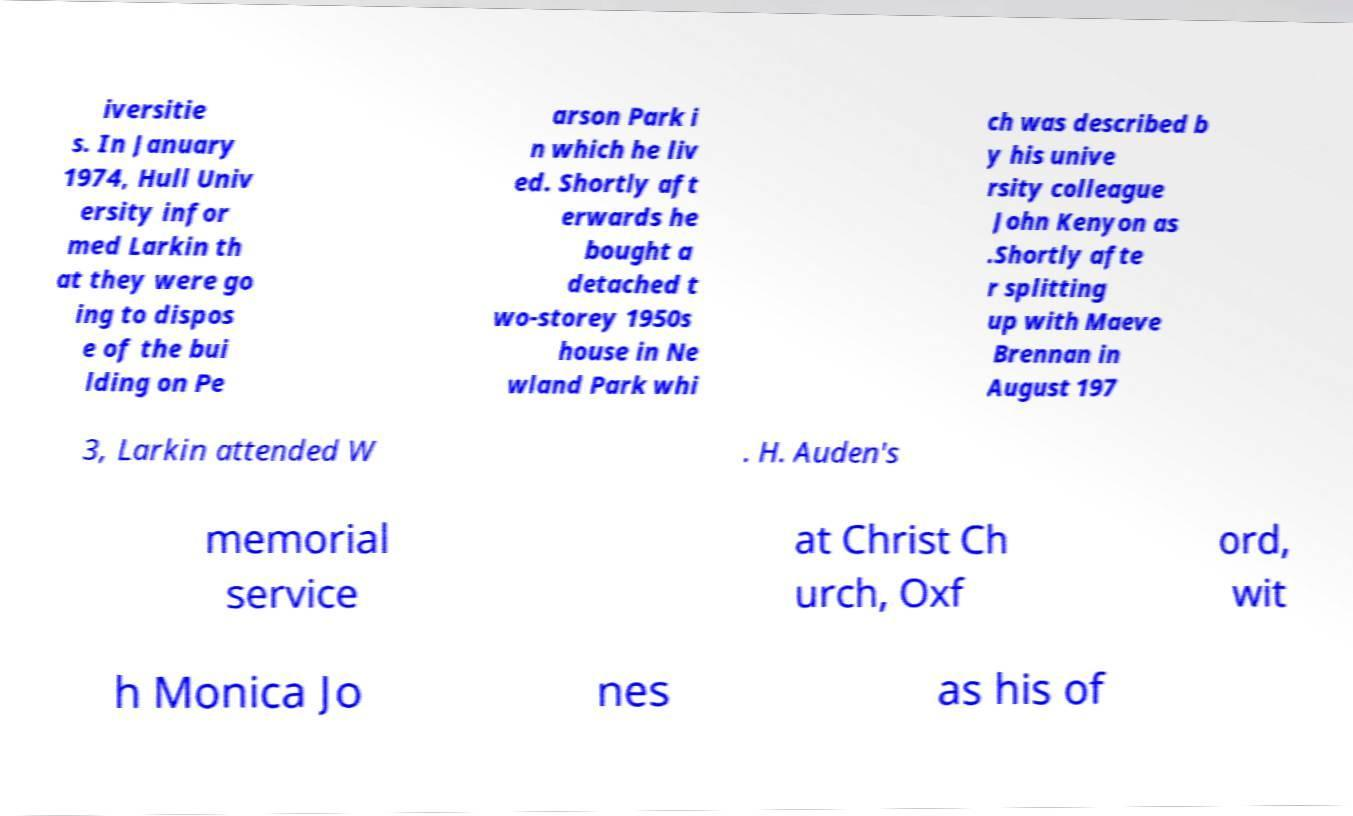Can you accurately transcribe the text from the provided image for me? iversitie s. In January 1974, Hull Univ ersity infor med Larkin th at they were go ing to dispos e of the bui lding on Pe arson Park i n which he liv ed. Shortly aft erwards he bought a detached t wo-storey 1950s house in Ne wland Park whi ch was described b y his unive rsity colleague John Kenyon as .Shortly afte r splitting up with Maeve Brennan in August 197 3, Larkin attended W . H. Auden's memorial service at Christ Ch urch, Oxf ord, wit h Monica Jo nes as his of 